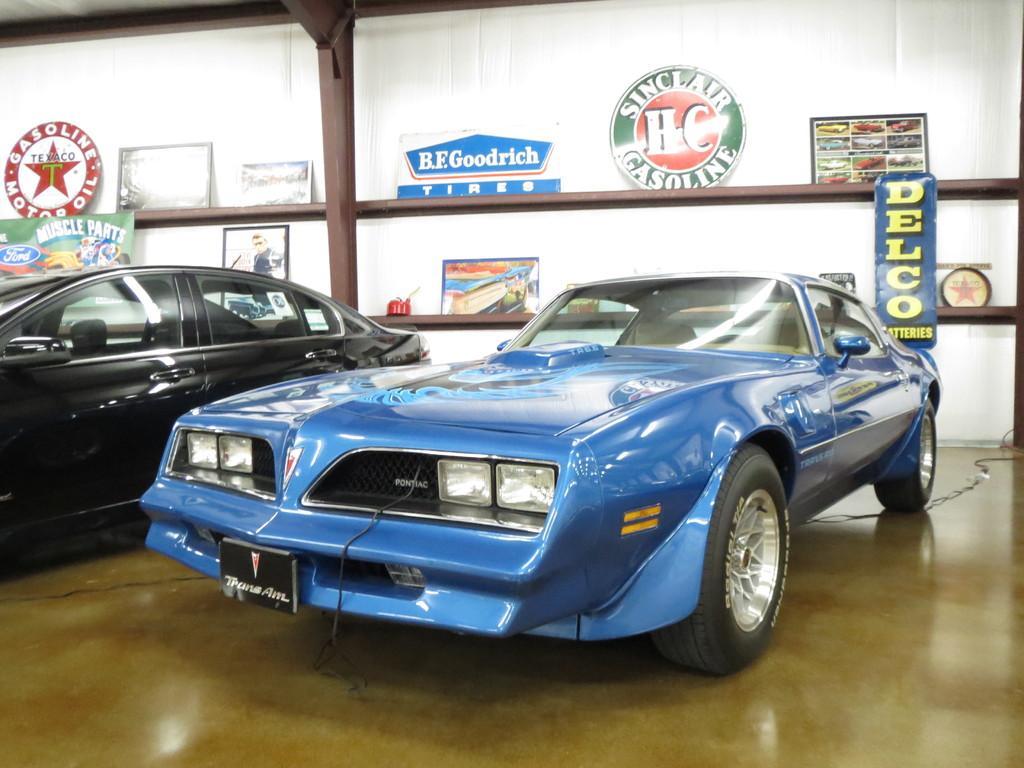In one or two sentences, can you explain what this image depicts? In this image, I can see cars and a wire on the floor. Behind the cars, I can see a pole and there are boards in the racks. In the background, it looks like a white wall. 